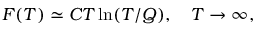<formula> <loc_0><loc_0><loc_500><loc_500>F ( T ) \simeq C T \ln ( T / Q ) , \quad T \to \infty ,</formula> 